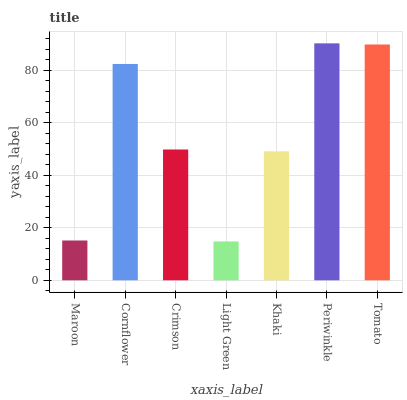Is Light Green the minimum?
Answer yes or no. Yes. Is Periwinkle the maximum?
Answer yes or no. Yes. Is Cornflower the minimum?
Answer yes or no. No. Is Cornflower the maximum?
Answer yes or no. No. Is Cornflower greater than Maroon?
Answer yes or no. Yes. Is Maroon less than Cornflower?
Answer yes or no. Yes. Is Maroon greater than Cornflower?
Answer yes or no. No. Is Cornflower less than Maroon?
Answer yes or no. No. Is Crimson the high median?
Answer yes or no. Yes. Is Crimson the low median?
Answer yes or no. Yes. Is Light Green the high median?
Answer yes or no. No. Is Tomato the low median?
Answer yes or no. No. 